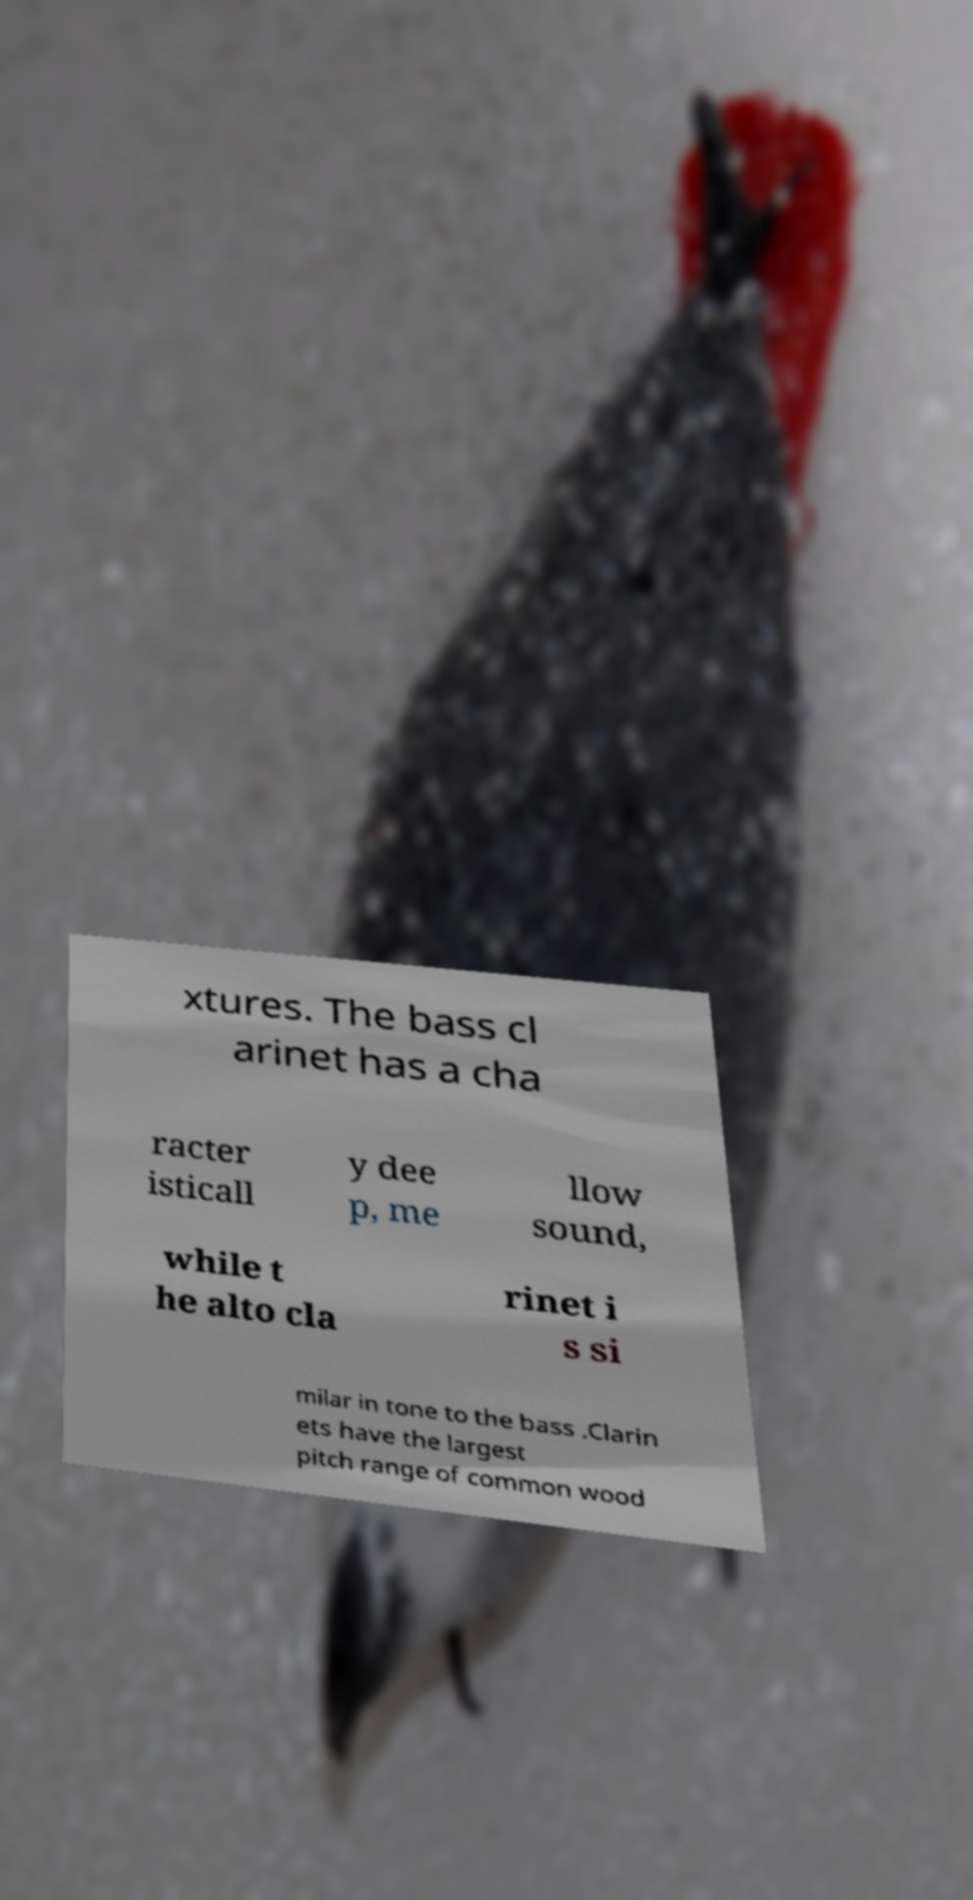I need the written content from this picture converted into text. Can you do that? xtures. The bass cl arinet has a cha racter isticall y dee p, me llow sound, while t he alto cla rinet i s si milar in tone to the bass .Clarin ets have the largest pitch range of common wood 